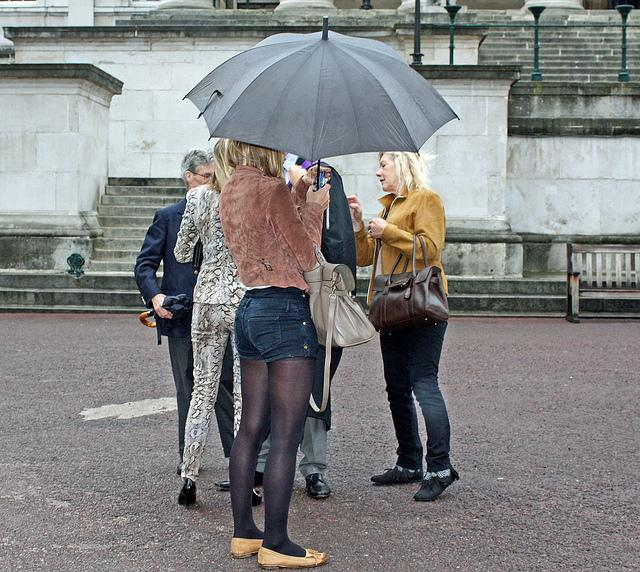From what materials is the wall made? stone 